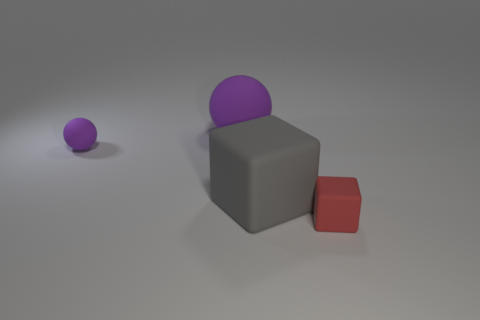What materials appear to be represented in this image? The image seems to depict objects with different materials. The large sphere and the small one are likely made of a matte material such as rubber, while the cube appears to have a metallic surface, and the small cube could be plastic due to its distinct sheen. 